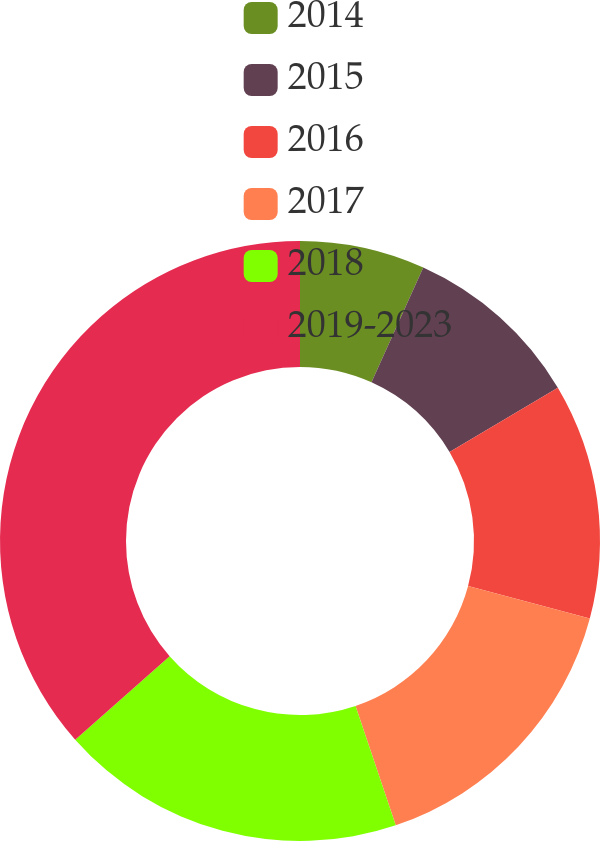Convert chart to OTSL. <chart><loc_0><loc_0><loc_500><loc_500><pie_chart><fcel>2014<fcel>2015<fcel>2016<fcel>2017<fcel>2018<fcel>2019-2023<nl><fcel>6.74%<fcel>9.72%<fcel>12.7%<fcel>15.67%<fcel>18.65%<fcel>36.52%<nl></chart> 